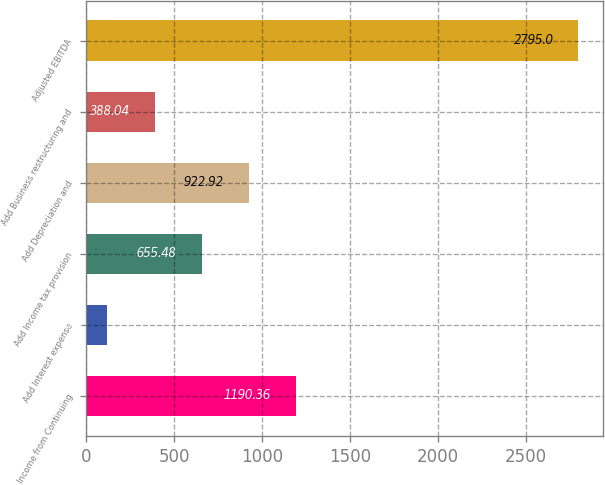<chart> <loc_0><loc_0><loc_500><loc_500><bar_chart><fcel>Income from Continuing<fcel>Add Interest expense<fcel>Add Income tax provision<fcel>Add Depreciation and<fcel>Add Business restructuring and<fcel>Adjusted EBITDA<nl><fcel>1190.36<fcel>120.6<fcel>655.48<fcel>922.92<fcel>388.04<fcel>2795<nl></chart> 